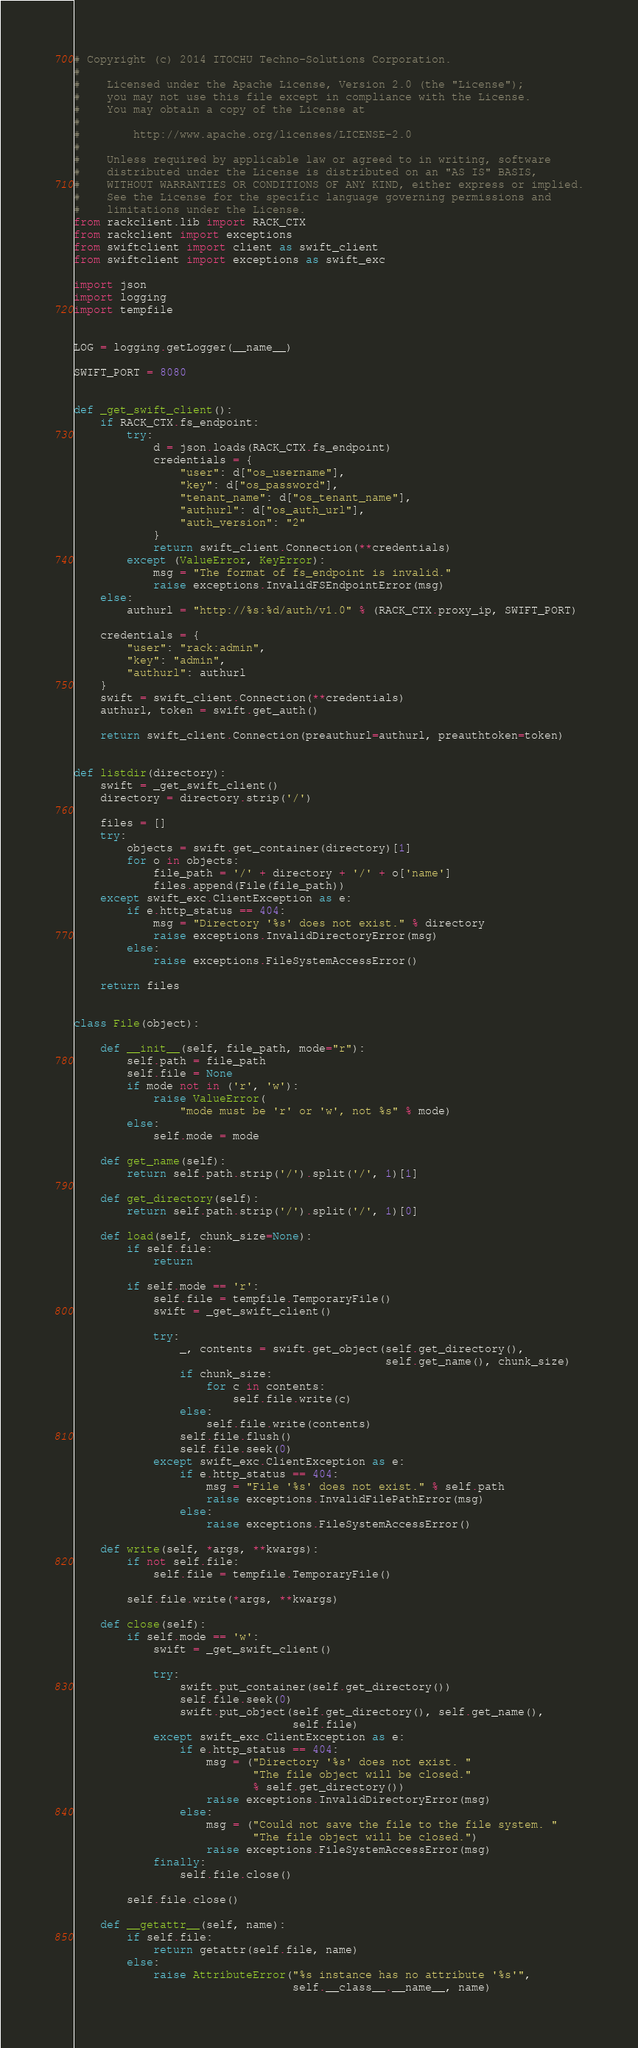<code> <loc_0><loc_0><loc_500><loc_500><_Python_># Copyright (c) 2014 ITOCHU Techno-Solutions Corporation.
#
#    Licensed under the Apache License, Version 2.0 (the "License");
#    you may not use this file except in compliance with the License.
#    You may obtain a copy of the License at
#
#        http://www.apache.org/licenses/LICENSE-2.0
#
#    Unless required by applicable law or agreed to in writing, software
#    distributed under the License is distributed on an "AS IS" BASIS,
#    WITHOUT WARRANTIES OR CONDITIONS OF ANY KIND, either express or implied.
#    See the License for the specific language governing permissions and
#    limitations under the License.
from rackclient.lib import RACK_CTX
from rackclient import exceptions
from swiftclient import client as swift_client
from swiftclient import exceptions as swift_exc

import json
import logging
import tempfile


LOG = logging.getLogger(__name__)

SWIFT_PORT = 8080


def _get_swift_client():
    if RACK_CTX.fs_endpoint:
        try:
            d = json.loads(RACK_CTX.fs_endpoint)
            credentials = {
                "user": d["os_username"],
                "key": d["os_password"],
                "tenant_name": d["os_tenant_name"],
                "authurl": d["os_auth_url"],
                "auth_version": "2"
            }
            return swift_client.Connection(**credentials)
        except (ValueError, KeyError):
            msg = "The format of fs_endpoint is invalid."
            raise exceptions.InvalidFSEndpointError(msg)
    else:
        authurl = "http://%s:%d/auth/v1.0" % (RACK_CTX.proxy_ip, SWIFT_PORT)

    credentials = {
        "user": "rack:admin",
        "key": "admin",
        "authurl": authurl
    }
    swift = swift_client.Connection(**credentials)
    authurl, token = swift.get_auth()

    return swift_client.Connection(preauthurl=authurl, preauthtoken=token)


def listdir(directory):
    swift = _get_swift_client()
    directory = directory.strip('/')

    files = []
    try:
        objects = swift.get_container(directory)[1]
        for o in objects:
            file_path = '/' + directory + '/' + o['name']
            files.append(File(file_path))
    except swift_exc.ClientException as e:
        if e.http_status == 404:
            msg = "Directory '%s' does not exist." % directory
            raise exceptions.InvalidDirectoryError(msg)
        else:
            raise exceptions.FileSystemAccessError()

    return files


class File(object):

    def __init__(self, file_path, mode="r"):
        self.path = file_path
        self.file = None
        if mode not in ('r', 'w'):
            raise ValueError(
                "mode must be 'r' or 'w', not %s" % mode)
        else:
            self.mode = mode

    def get_name(self):
        return self.path.strip('/').split('/', 1)[1]

    def get_directory(self):
        return self.path.strip('/').split('/', 1)[0]

    def load(self, chunk_size=None):
        if self.file:
            return

        if self.mode == 'r':
            self.file = tempfile.TemporaryFile()
            swift = _get_swift_client()

            try:
                _, contents = swift.get_object(self.get_directory(),
                                               self.get_name(), chunk_size)
                if chunk_size:
                    for c in contents:
                        self.file.write(c)
                else:
                    self.file.write(contents)
                self.file.flush()
                self.file.seek(0)
            except swift_exc.ClientException as e:
                if e.http_status == 404:
                    msg = "File '%s' does not exist." % self.path
                    raise exceptions.InvalidFilePathError(msg)
                else:
                    raise exceptions.FileSystemAccessError()

    def write(self, *args, **kwargs):
        if not self.file:
            self.file = tempfile.TemporaryFile()

        self.file.write(*args, **kwargs)

    def close(self):
        if self.mode == 'w':
            swift = _get_swift_client()

            try:
                swift.put_container(self.get_directory())
                self.file.seek(0)
                swift.put_object(self.get_directory(), self.get_name(),
                                 self.file)
            except swift_exc.ClientException as e:
                if e.http_status == 404:
                    msg = ("Directory '%s' does not exist. "
                           "The file object will be closed."
                           % self.get_directory())
                    raise exceptions.InvalidDirectoryError(msg)
                else:
                    msg = ("Could not save the file to the file system. "
                           "The file object will be closed.")
                    raise exceptions.FileSystemAccessError(msg)
            finally:
                self.file.close()

        self.file.close()

    def __getattr__(self, name):
        if self.file:
            return getattr(self.file, name)
        else:
            raise AttributeError("%s instance has no attribute '%s'",
                                 self.__class__.__name__, name)
</code> 